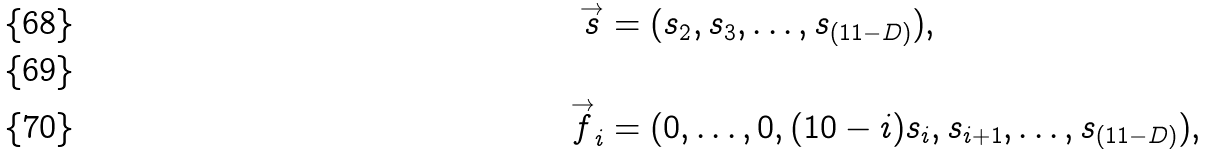<formula> <loc_0><loc_0><loc_500><loc_500>\overset { \rightarrow } { s } & = ( s _ { 2 } , s _ { 3 } , \dots , s _ { ( 1 1 - D ) } ) , \\ \\ \overset { \rightarrow } { f } _ { i } & = ( 0 , \dots , 0 , ( 1 0 - i ) s _ { i } , s _ { i + 1 } , \dots , s _ { ( 1 1 - D ) } ) ,</formula> 